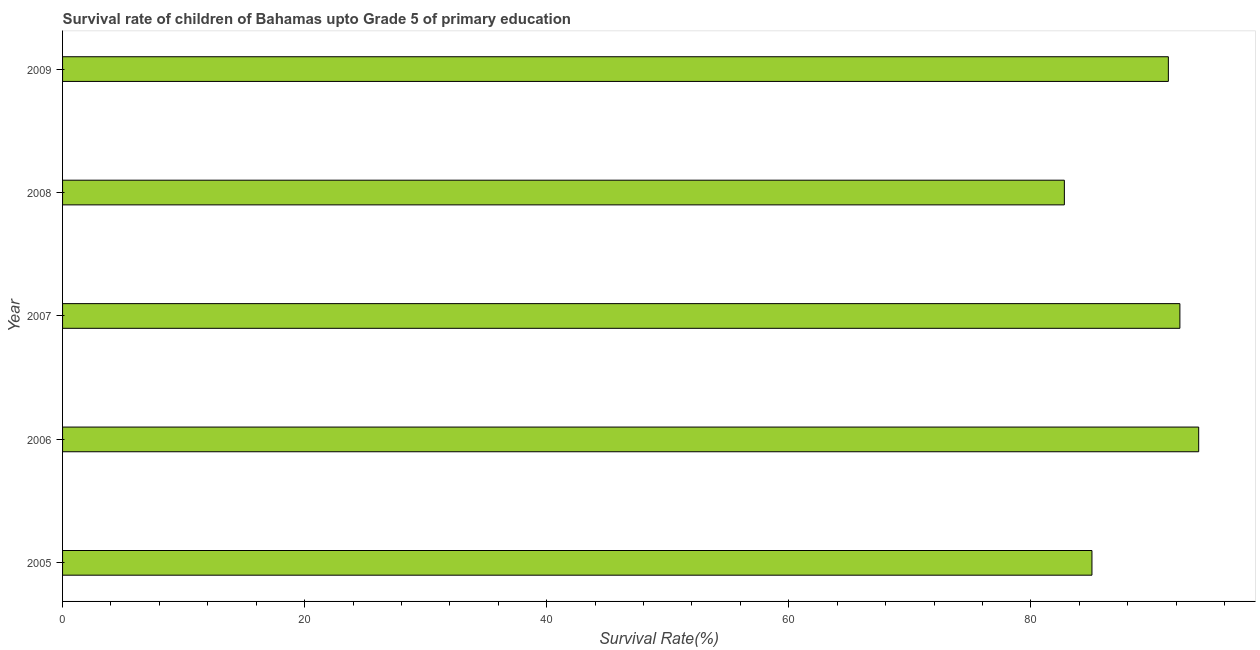Does the graph contain grids?
Make the answer very short. No. What is the title of the graph?
Give a very brief answer. Survival rate of children of Bahamas upto Grade 5 of primary education. What is the label or title of the X-axis?
Your response must be concise. Survival Rate(%). What is the label or title of the Y-axis?
Your answer should be very brief. Year. What is the survival rate in 2009?
Your answer should be very brief. 91.36. Across all years, what is the maximum survival rate?
Provide a short and direct response. 93.87. Across all years, what is the minimum survival rate?
Your answer should be compact. 82.77. In which year was the survival rate maximum?
Provide a succinct answer. 2006. What is the sum of the survival rate?
Keep it short and to the point. 445.36. What is the difference between the survival rate in 2006 and 2009?
Your answer should be compact. 2.51. What is the average survival rate per year?
Make the answer very short. 89.07. What is the median survival rate?
Provide a succinct answer. 91.36. Do a majority of the years between 2009 and 2006 (inclusive) have survival rate greater than 24 %?
Keep it short and to the point. Yes. What is the ratio of the survival rate in 2008 to that in 2009?
Ensure brevity in your answer.  0.91. What is the difference between the highest and the second highest survival rate?
Provide a succinct answer. 1.55. Is the sum of the survival rate in 2005 and 2008 greater than the maximum survival rate across all years?
Provide a succinct answer. Yes. In how many years, is the survival rate greater than the average survival rate taken over all years?
Ensure brevity in your answer.  3. Are the values on the major ticks of X-axis written in scientific E-notation?
Offer a terse response. No. What is the Survival Rate(%) in 2005?
Offer a terse response. 85.05. What is the Survival Rate(%) in 2006?
Offer a very short reply. 93.87. What is the Survival Rate(%) of 2007?
Offer a terse response. 92.32. What is the Survival Rate(%) of 2008?
Provide a succinct answer. 82.77. What is the Survival Rate(%) of 2009?
Offer a terse response. 91.36. What is the difference between the Survival Rate(%) in 2005 and 2006?
Provide a short and direct response. -8.82. What is the difference between the Survival Rate(%) in 2005 and 2007?
Your response must be concise. -7.27. What is the difference between the Survival Rate(%) in 2005 and 2008?
Ensure brevity in your answer.  2.28. What is the difference between the Survival Rate(%) in 2005 and 2009?
Your answer should be very brief. -6.31. What is the difference between the Survival Rate(%) in 2006 and 2007?
Offer a very short reply. 1.55. What is the difference between the Survival Rate(%) in 2006 and 2008?
Your response must be concise. 11.1. What is the difference between the Survival Rate(%) in 2006 and 2009?
Give a very brief answer. 2.51. What is the difference between the Survival Rate(%) in 2007 and 2008?
Your answer should be compact. 9.54. What is the difference between the Survival Rate(%) in 2007 and 2009?
Provide a succinct answer. 0.95. What is the difference between the Survival Rate(%) in 2008 and 2009?
Make the answer very short. -8.59. What is the ratio of the Survival Rate(%) in 2005 to that in 2006?
Your answer should be very brief. 0.91. What is the ratio of the Survival Rate(%) in 2005 to that in 2007?
Give a very brief answer. 0.92. What is the ratio of the Survival Rate(%) in 2005 to that in 2008?
Provide a short and direct response. 1.03. What is the ratio of the Survival Rate(%) in 2005 to that in 2009?
Ensure brevity in your answer.  0.93. What is the ratio of the Survival Rate(%) in 2006 to that in 2007?
Keep it short and to the point. 1.02. What is the ratio of the Survival Rate(%) in 2006 to that in 2008?
Offer a terse response. 1.13. What is the ratio of the Survival Rate(%) in 2007 to that in 2008?
Keep it short and to the point. 1.11. What is the ratio of the Survival Rate(%) in 2008 to that in 2009?
Ensure brevity in your answer.  0.91. 